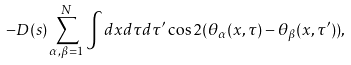<formula> <loc_0><loc_0><loc_500><loc_500>- D ( s ) \sum _ { \alpha , \beta = 1 } ^ { N } \int d x d \tau d \tau ^ { \prime } \cos 2 ( \theta _ { \alpha } ( x , \tau ) - \theta _ { \beta } ( x , \tau ^ { \prime } ) ) ,</formula> 